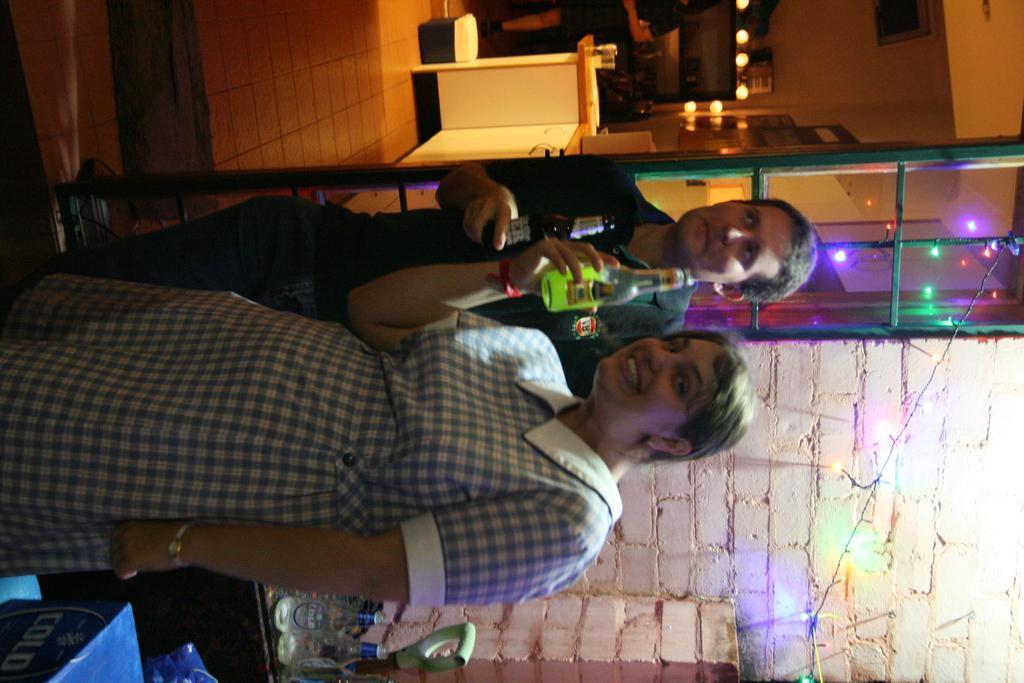Could you give a brief overview of what you see in this image? Here in this picture we can see a man and a woman standing over a place and we can see both of them are holding bottles in their hands and the woman is smiling and the man is leaning on the pole and behind them we can see cupboards present and we can see colorful lights present and on the counter top we can see glasses present and beside them we can see bottles present on the table over there. 